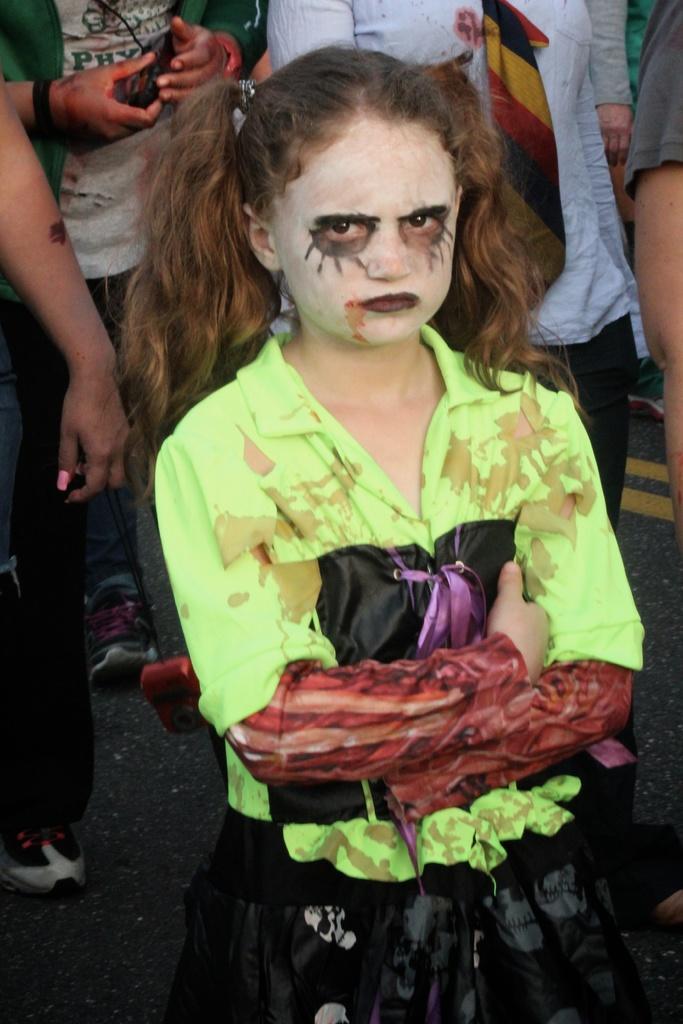In one or two sentences, can you explain what this image depicts? In this image I can see number of people are standing. Here I can see she is wearing neon colour dress. I can also see face paint on her face. 